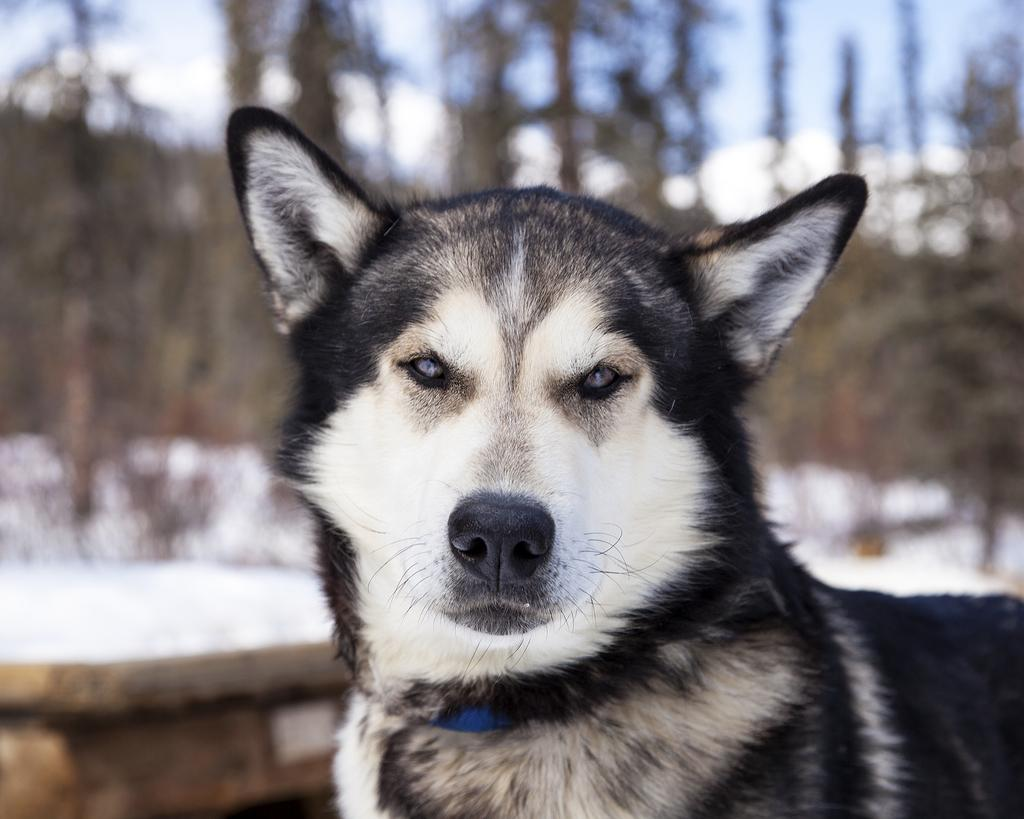What type of animal is in the image? The type of animal cannot be determined from the provided facts. Can you describe the background of the image? There might be a tree in the background of the image, and the sky is visible. What type of pencil is the animal holding in the image? There is no pencil present in the image, and the animal is not holding anything. What kind of agreement is being made between the animal and the tree in the image? There is no agreement being made between the animal and the tree in the image, as there is no indication of any interaction or communication between them. 